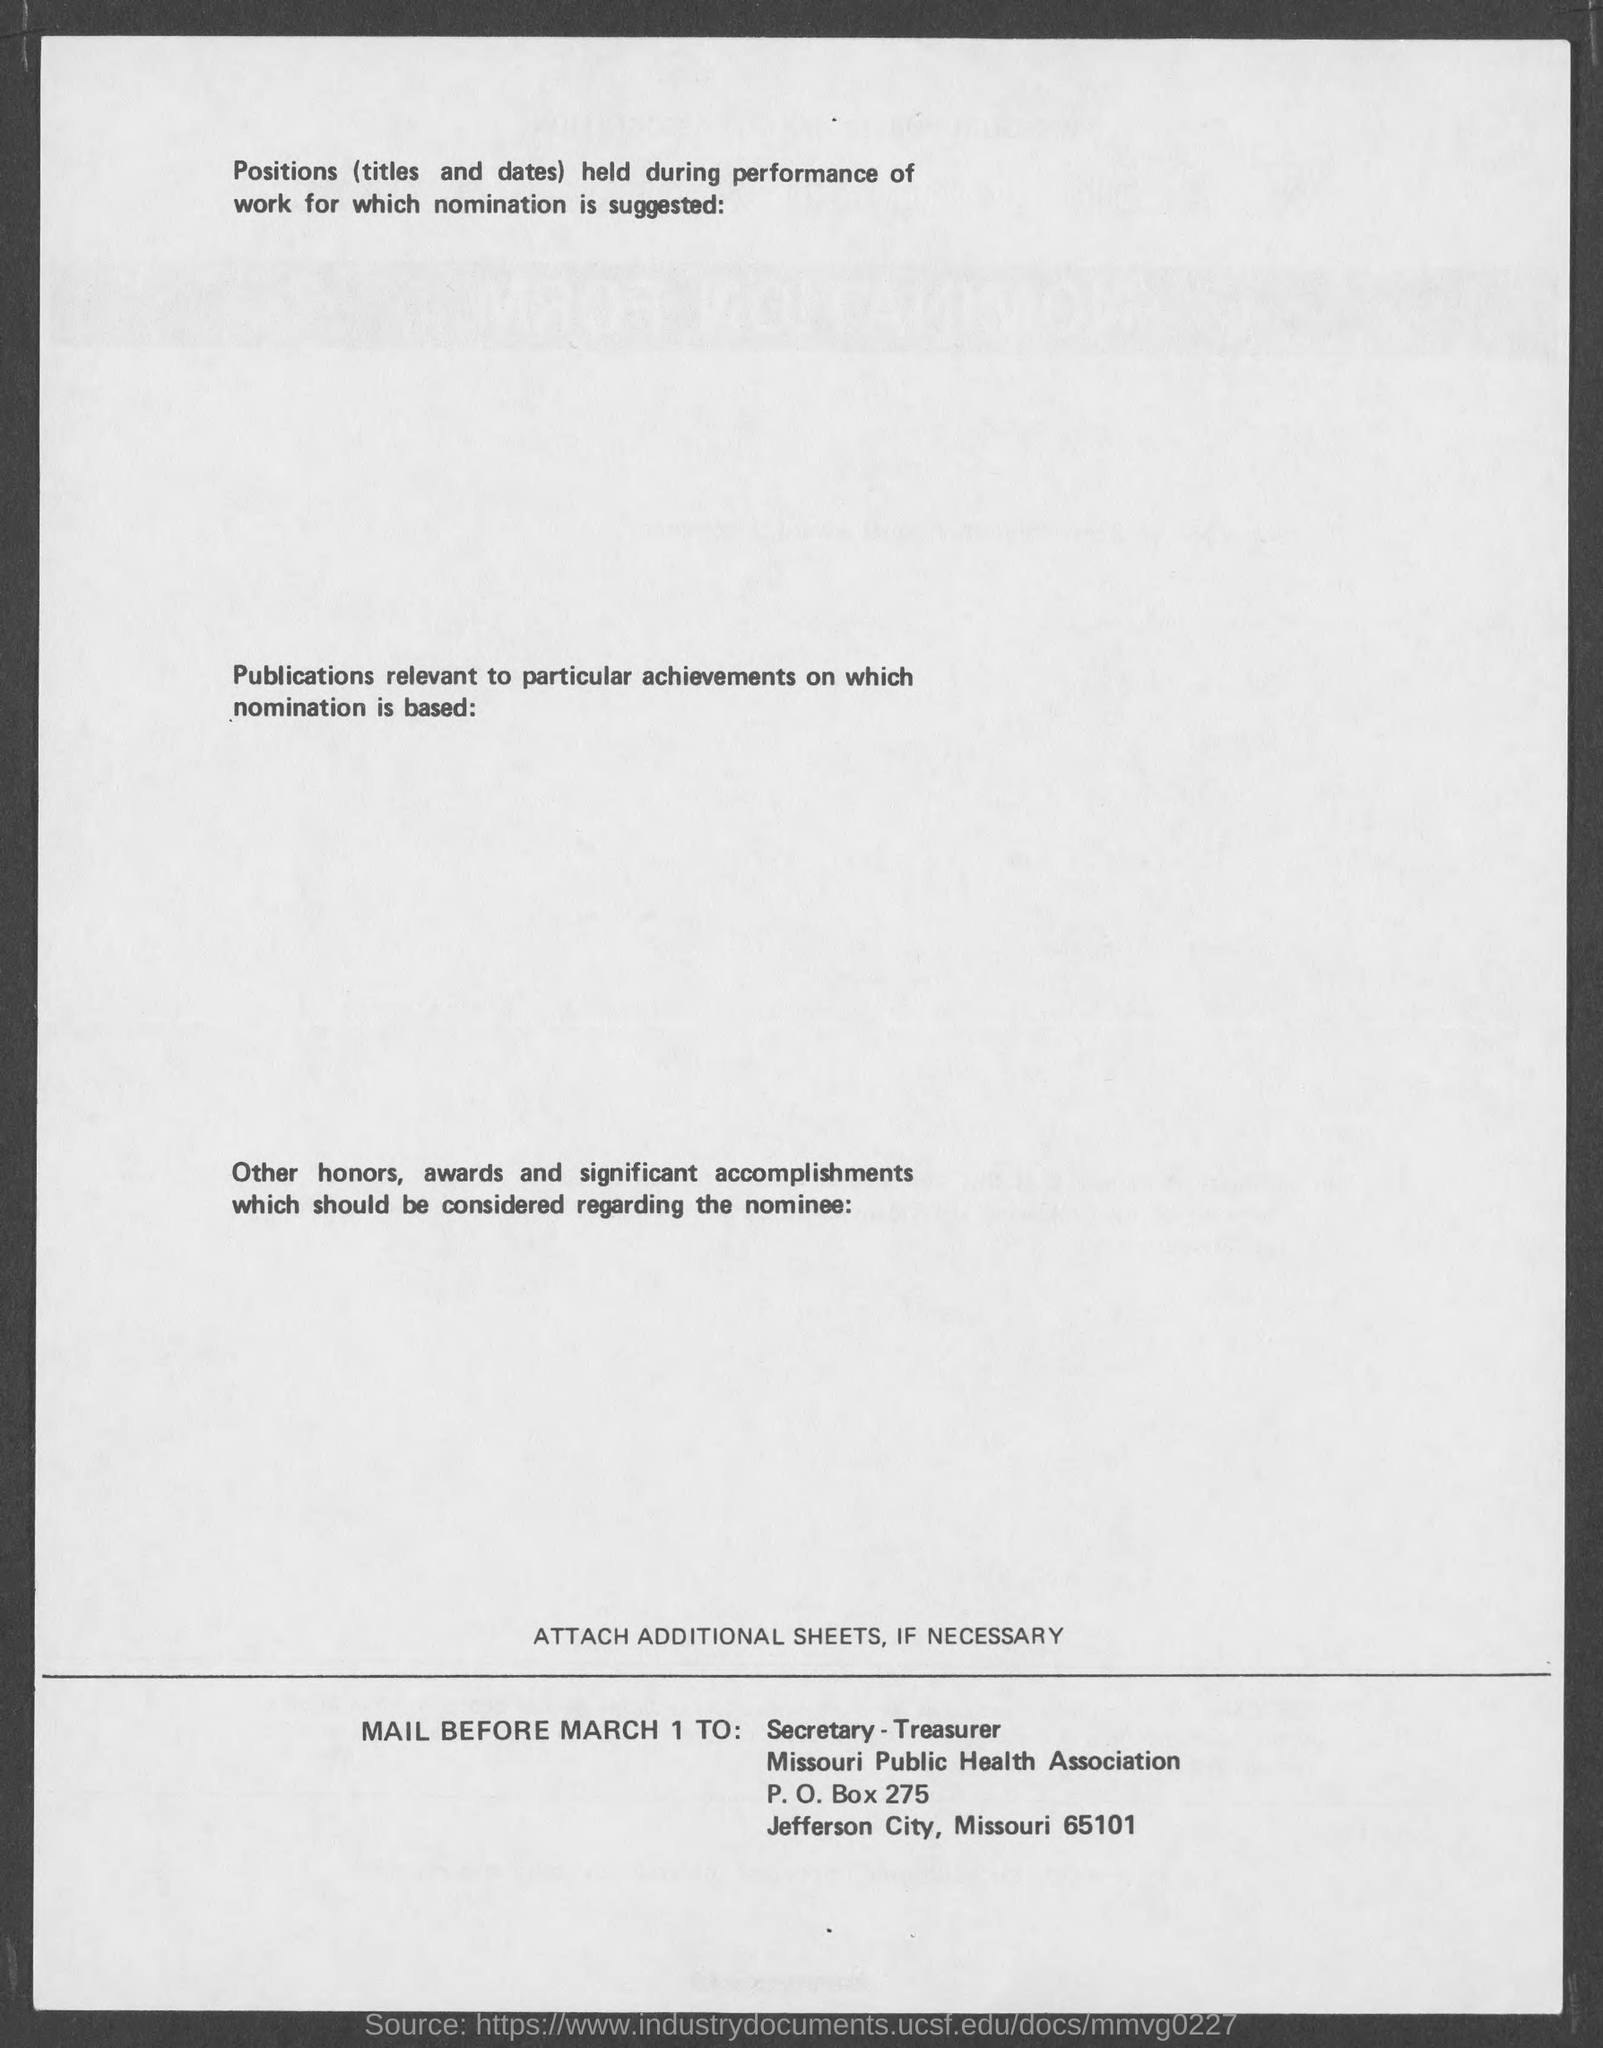What is the city name mentioned in the document?
Offer a terse response. Jefferson City,Missouri. What is the ZIP code?
Offer a very short reply. 65101. What is the P.O Box number?
Keep it short and to the point. 275. 